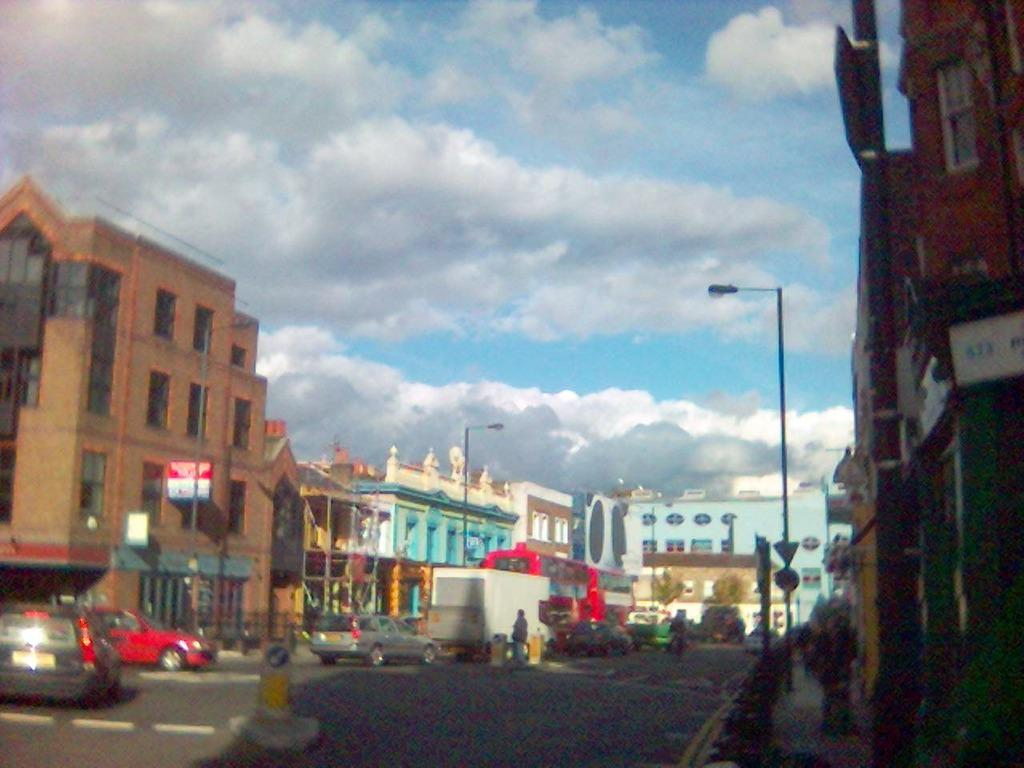What is happening on the road in the image? There are vehicles on the road in the image. What can be seen in the distance behind the vehicles? There are buildings, poles, and other objects in the background of the image. What part of the natural environment is visible in the image? The sky is visible in the image. Can you hear the bell ringing in the image? There is no bell present in the image, so it cannot be heard. 